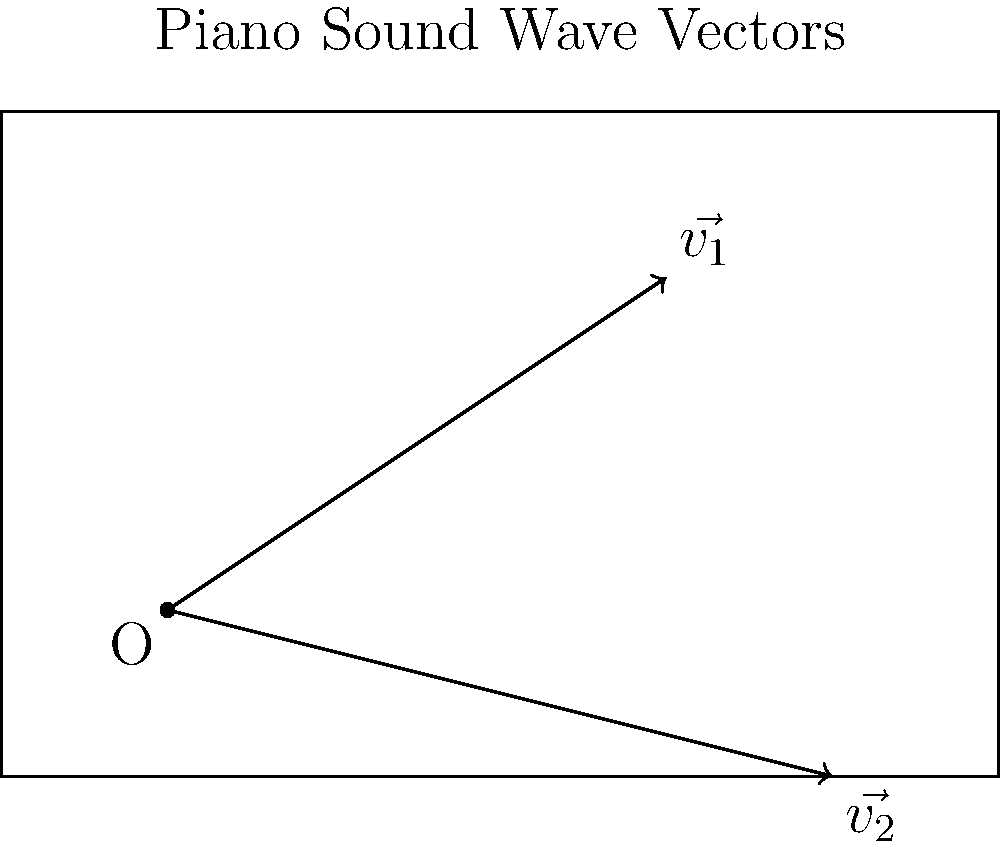In the diagram above, two vectors $\vec{v_1}$ and $\vec{v_2}$ represent the trajectories of sound waves from different parts of a piano. Vector $\vec{v_1}$ has components (3, 2), and $\vec{v_2}$ has components (4, -1). Calculate the magnitude of the resultant vector $\vec{v_R} = \vec{v_1} + \vec{v_2}$. To find the magnitude of the resultant vector $\vec{v_R}$, we need to follow these steps:

1) First, add the two vectors $\vec{v_1}$ and $\vec{v_2}$:
   $\vec{v_R} = \vec{v_1} + \vec{v_2}$
   
2) Add the x-components: 3 + 4 = 7
   Add the y-components: 2 + (-1) = 1
   
   So, $\vec{v_R} = (7, 1)$

3) To find the magnitude of $\vec{v_R}$, we use the Pythagorean theorem:
   $|\vec{v_R}| = \sqrt{x^2 + y^2}$

4) Substitute the values:
   $|\vec{v_R}| = \sqrt{7^2 + 1^2}$

5) Calculate:
   $|\vec{v_R}| = \sqrt{49 + 1} = \sqrt{50}$

6) Simplify:
   $|\vec{v_R}| = 5\sqrt{2}$

Therefore, the magnitude of the resultant vector $\vec{v_R}$ is $5\sqrt{2}$.
Answer: $5\sqrt{2}$ 